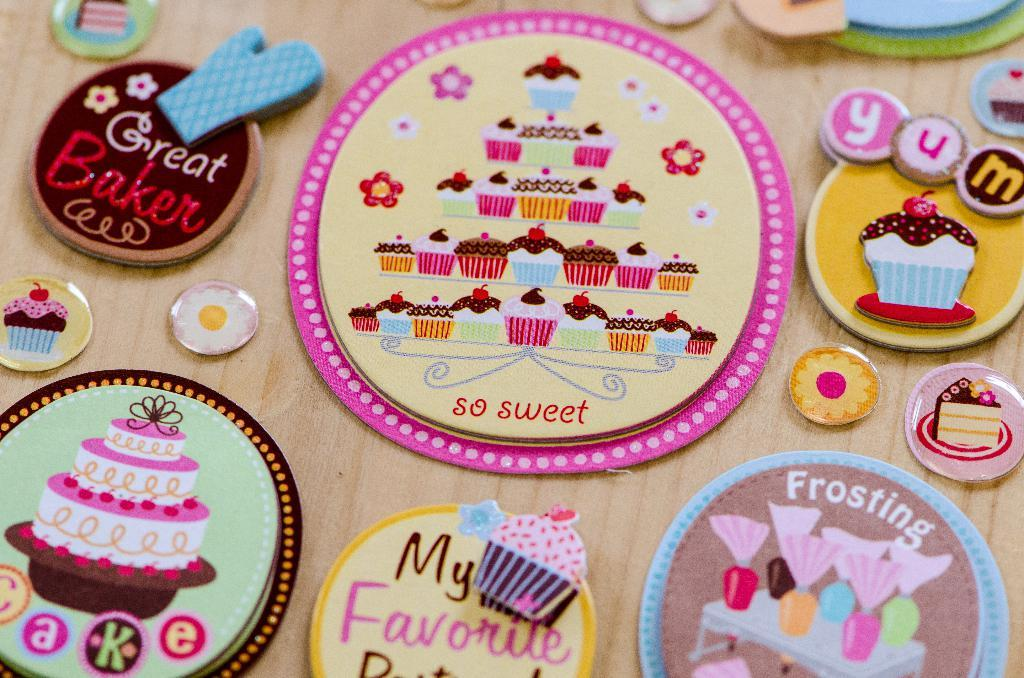What type of objects can be seen in the image? There are handcrafts in the image. What material is the surface on which the handcrafts are placed? There is a wooden surface in the image. What type of stew is being prepared in the image? There is no stew present in the image; it features handcrafts on a wooden surface. 